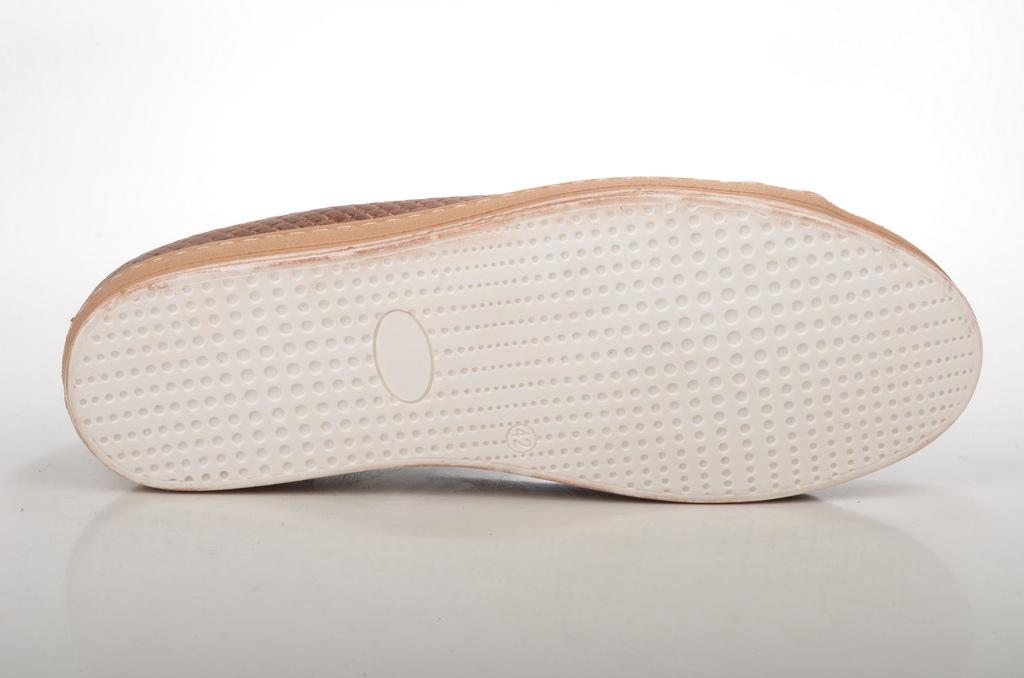What object is on the floor in the image? There is a shoe present in the image. Can you describe the position of the shoe in the image? The shoe is on the floor. What type of tooth can be seen in the image? There is no tooth present in the image; it only features a shoe on the floor. 